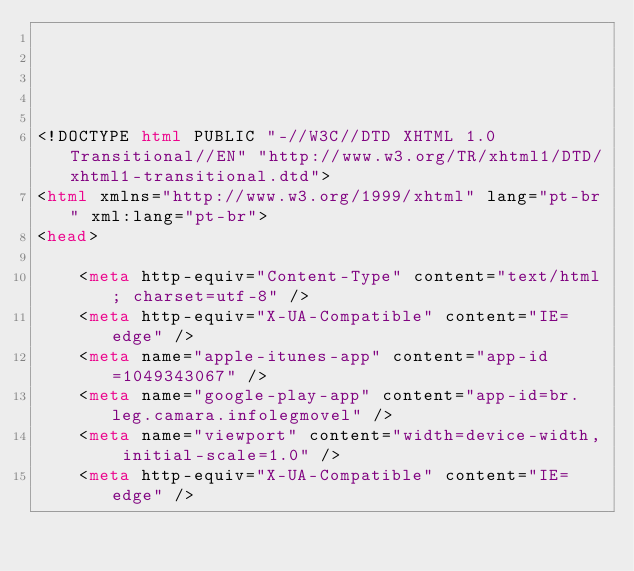Convert code to text. <code><loc_0><loc_0><loc_500><loc_500><_HTML_>




<!DOCTYPE html PUBLIC "-//W3C//DTD XHTML 1.0 Transitional//EN" "http://www.w3.org/TR/xhtml1/DTD/xhtml1-transitional.dtd">
<html xmlns="http://www.w3.org/1999/xhtml" lang="pt-br" xml:lang="pt-br">
<head>
	    
    <meta http-equiv="Content-Type" content="text/html; charset=utf-8" />
    <meta http-equiv="X-UA-Compatible" content="IE=edge" />
    <meta name="apple-itunes-app" content="app-id=1049343067" />
    <meta name="google-play-app" content="app-id=br.leg.camara.infolegmovel" />
    <meta name="viewport" content="width=device-width, initial-scale=1.0" />
	<meta http-equiv="X-UA-Compatible" content="IE=edge" /> 
    </code> 